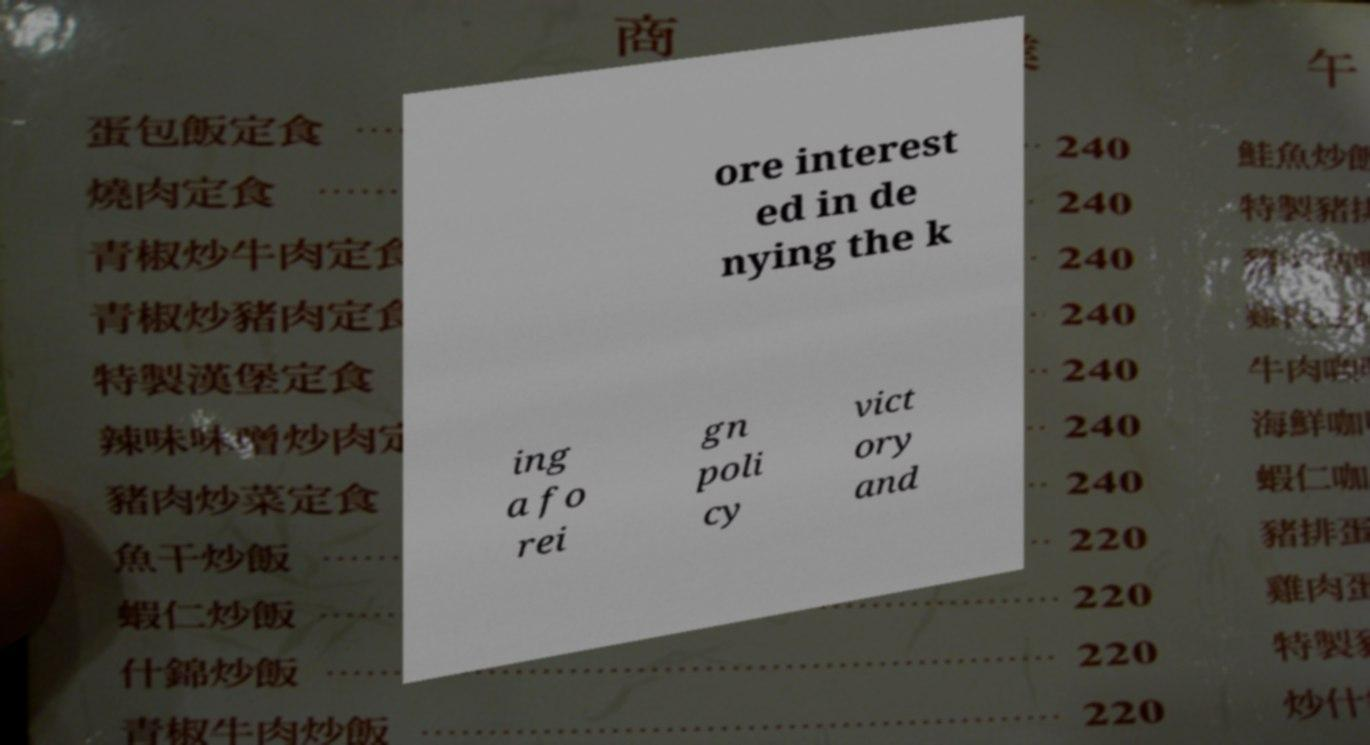Could you extract and type out the text from this image? ore interest ed in de nying the k ing a fo rei gn poli cy vict ory and 